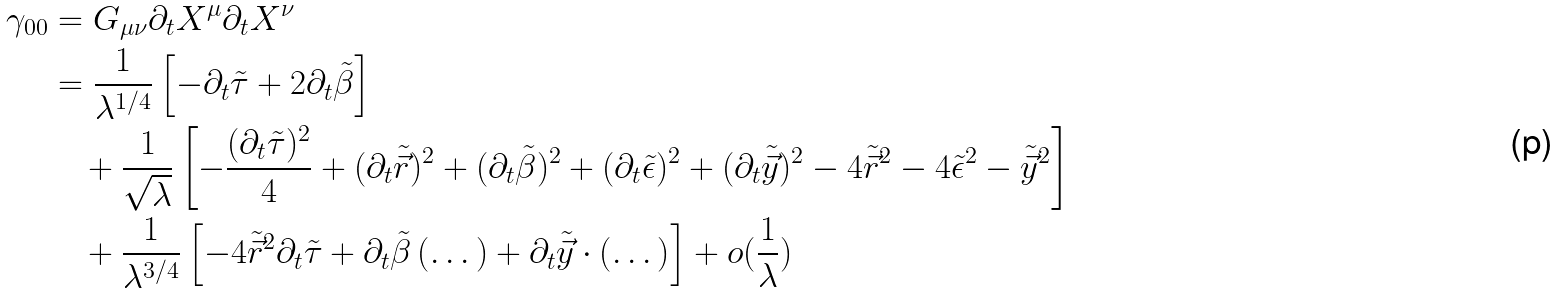<formula> <loc_0><loc_0><loc_500><loc_500>\gamma _ { 0 0 } & = G _ { \mu \nu } \partial _ { t } X ^ { \mu } \partial _ { t } X ^ { \nu } \\ & = \frac { 1 } { \lambda ^ { 1 / 4 } } \left [ - \partial _ { t } \tilde { \tau } + 2 \partial _ { t } \tilde { \beta } \right ] \\ & \quad + \frac { 1 } { \sqrt { \lambda } } \left [ - \frac { ( \partial _ { t } \tilde { \tau } ) ^ { 2 } } { 4 } + ( \partial _ { t } \tilde { \vec { r } } ) ^ { 2 } + ( \partial _ { t } \tilde { \beta } ) ^ { 2 } + ( \partial _ { t } \tilde { \epsilon } ) ^ { 2 } + ( \partial _ { t } \tilde { \vec { y } } ) ^ { 2 } - 4 \tilde { \vec { r } } ^ { 2 } - 4 \tilde { \epsilon } ^ { 2 } - \tilde { \vec { y } } ^ { 2 } \right ] \\ & \quad + \frac { 1 } { \lambda ^ { 3 / 4 } } \left [ - 4 \tilde { \vec { r } } ^ { 2 } \partial _ { t } \tilde { \tau } + \partial _ { t } \tilde { \beta } \left ( \dots \right ) + \partial _ { t } \tilde { \vec { y } } \cdot \left ( \dots \right ) \right ] + o ( \frac { 1 } { \lambda } )</formula> 